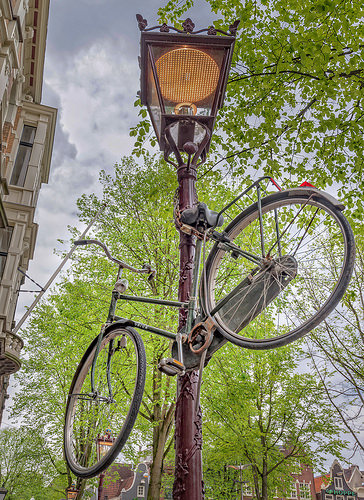<image>
Can you confirm if the bike is on the lamp? Yes. Looking at the image, I can see the bike is positioned on top of the lamp, with the lamp providing support. 